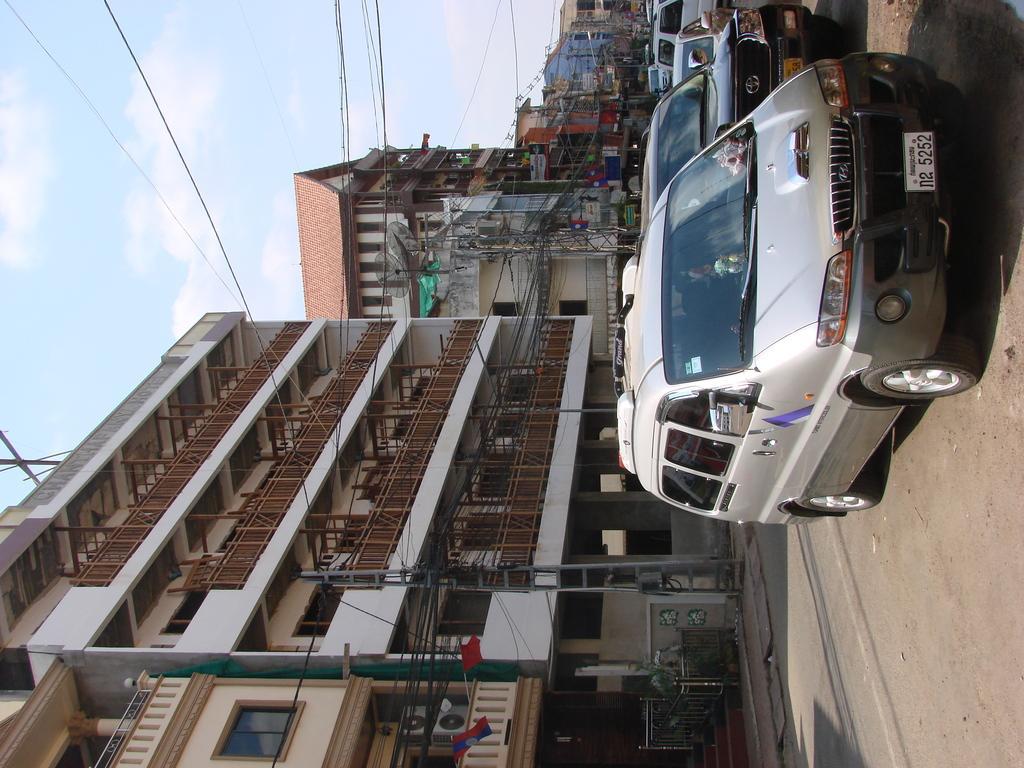Describe this image in one or two sentences. In the right bottom of the picture, we see the road. On the right side, we see cars which are parked on the road. On the left side, there are many buildings, electric poles and wires. In the background, there are buildings. In the left top of the picture, we see the sky and the clouds. This picture is clicked outside the city. 